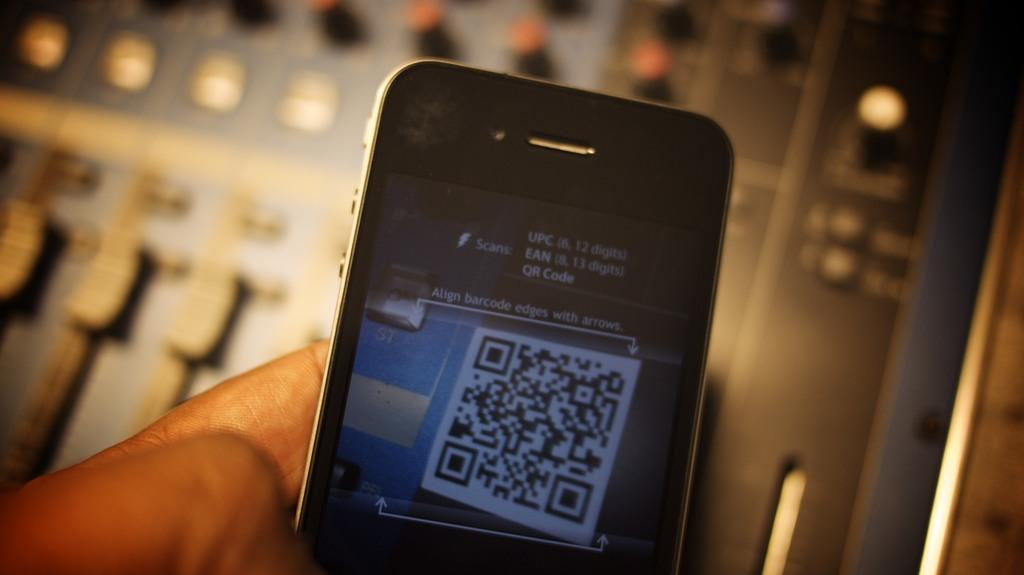<image>
Provide a brief description of the given image. A close up of a phone with a QR code on its screen. 